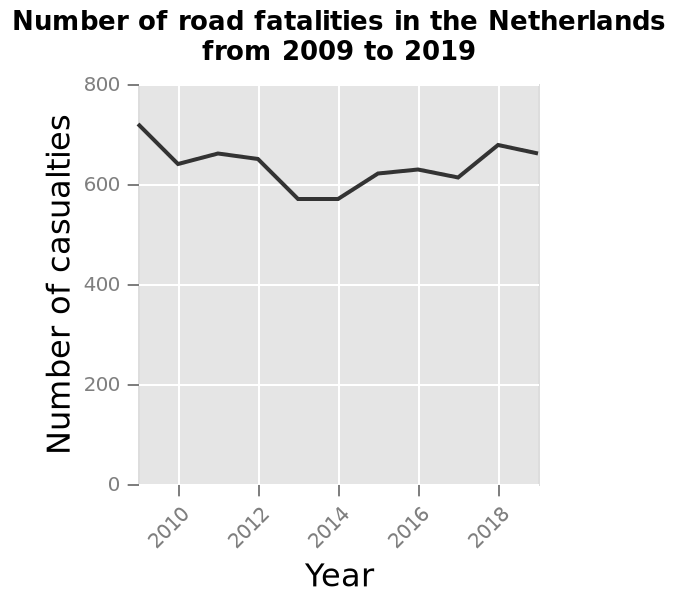<image>
What is represented on the y-axis of the line graph?  The number of casualties. 